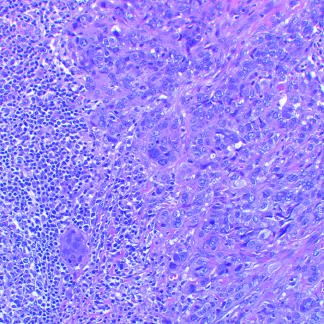do characteristic peribronchial noncaseating granulomas with many giant cells consist of tightly adhesive clusters of cells, as in this carcinoma with medullary features, or when there is abundant extracellular mucin production?
Answer the question using a single word or phrase. No 